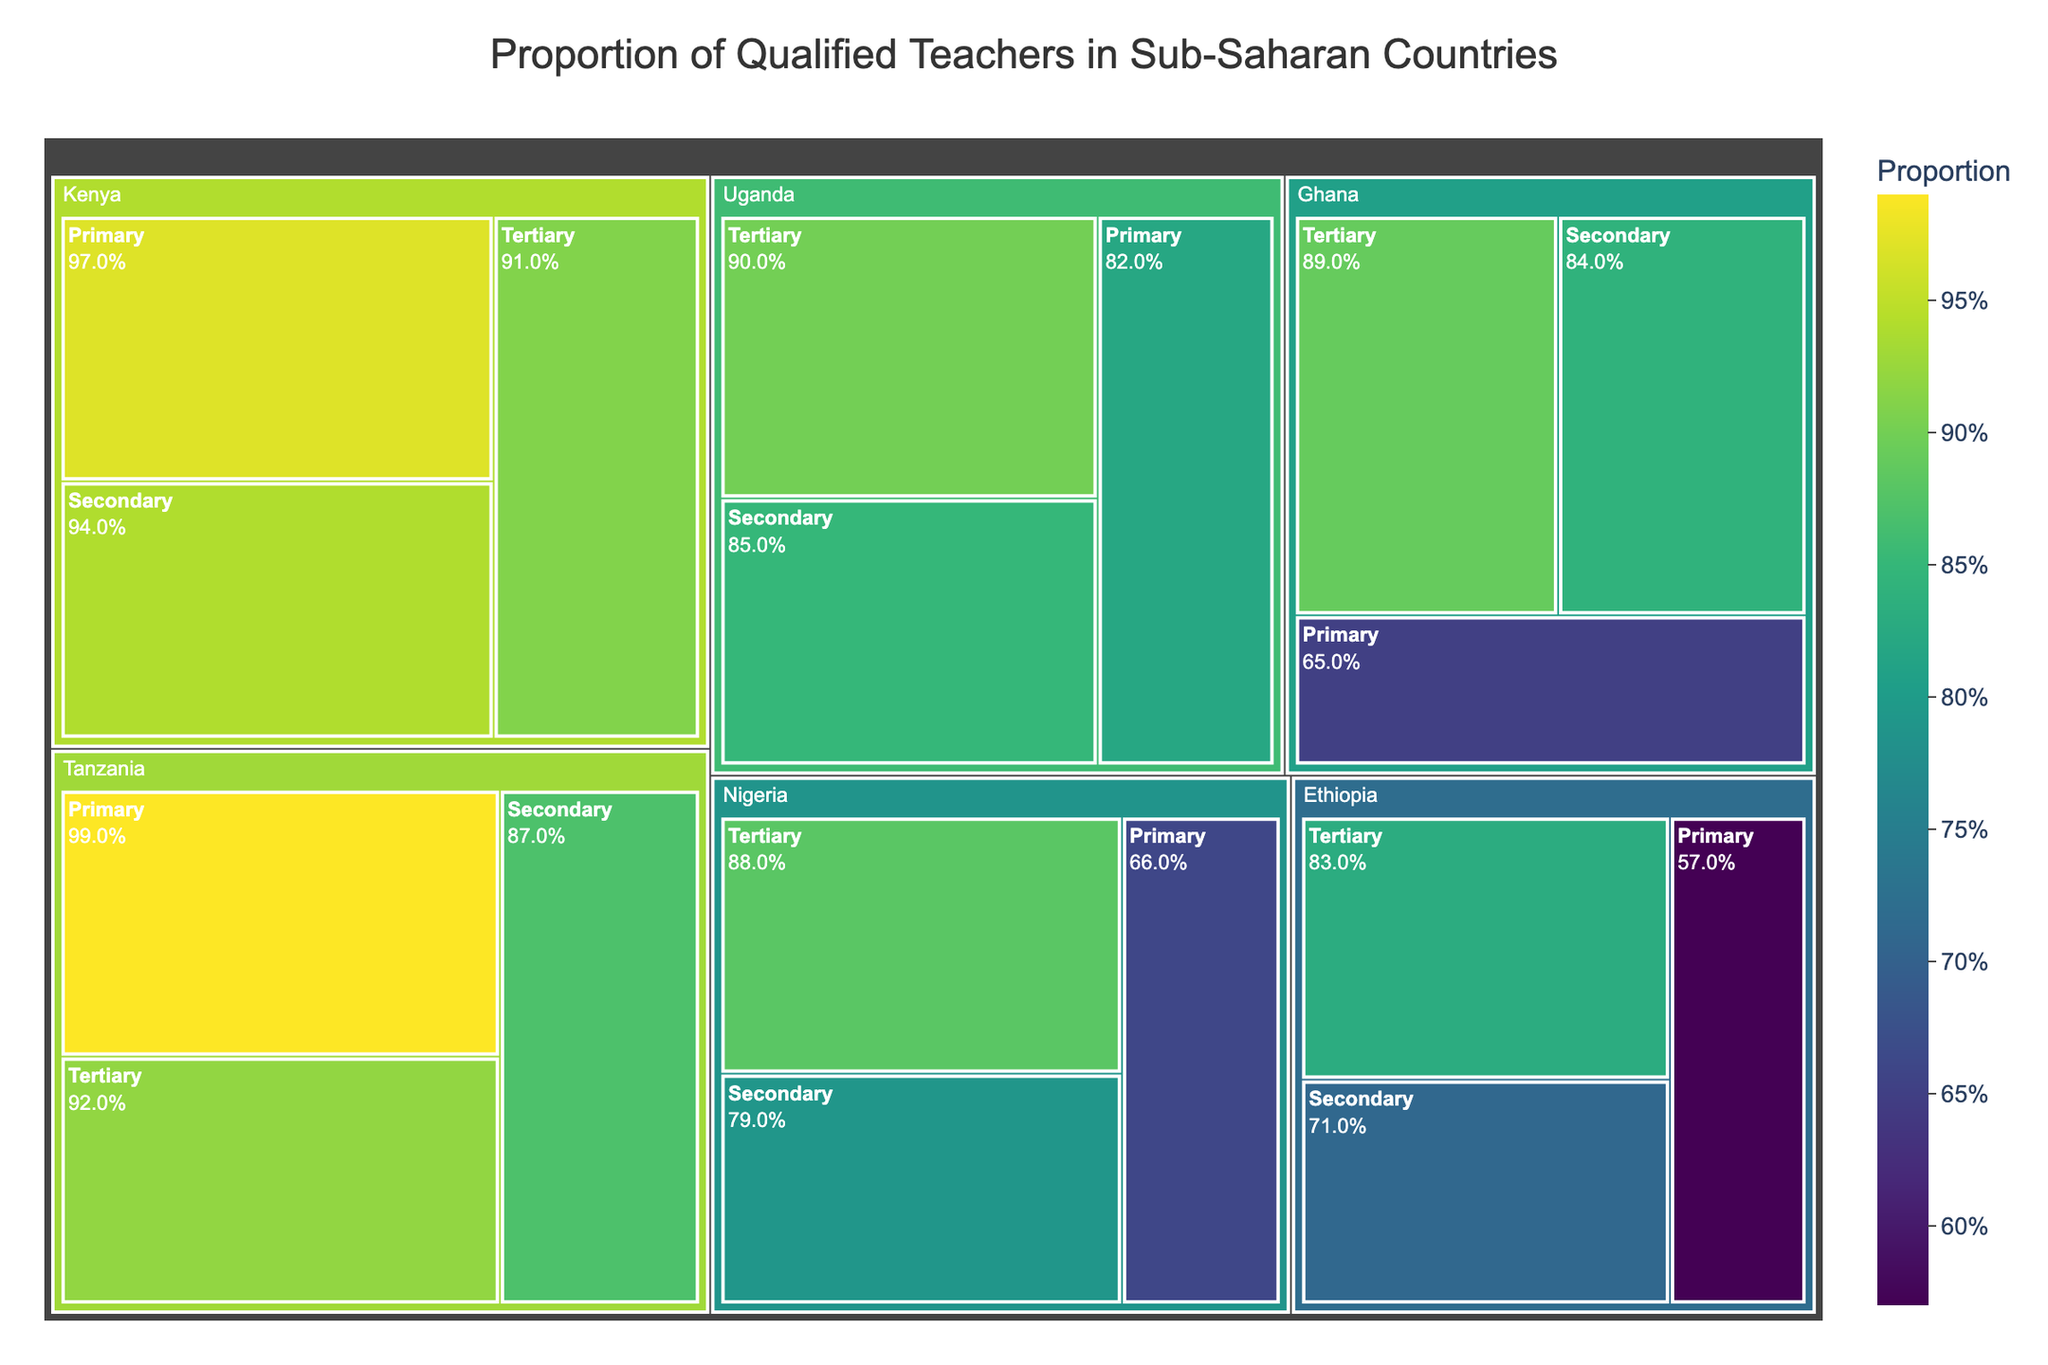What is the title of the treemap? The title is usually found at the top center of the plot. It provides a general idea of what the figure represents. In this case, the title describes the content of the treemap.
Answer: Proportion of Qualified Teachers in Sub-Saharan Countries Which country has the highest proportion of qualified primary school teachers? Look for the largest proportion in the section of the treemap corresponding to primary education. Identify the country associated with this section. Tanzania at 0.99 has the highest proportion.
Answer: Tanzania How does the proportion of qualified tertiary teachers in Uganda compare to that in Nigeria? Locate the sections for tertiary education in both Uganda and Nigeria. Compare the values to determine which is higher. Uganda has 0.90 and Nigeria has 0.88.
Answer: Uganda What is the range of the proportions of qualified secondary school teachers across all countries? Identify the minimum and maximum proportions from the sections representing secondary education in all the countries and find the difference. The lowest proportion is 0.71 (Ethiopia) and the highest is 0.94 (Kenya).
Answer: 0.23 What is the average proportion of qualified teachers at the primary education level across all listed countries? Sum the proportions of all countries in the Primary education section and divide by the number of countries (5). The sum is 0.66 + 0.97 + 0.57 + 0.65 + 0.99 + 0.82 = 4.66. The average is 4.66/6.
Answer: 0.78 Which education level in Tanzania has the lowest proportion of qualified teachers and what is the value? Look for the smallest section within Tanzania's part of the treemap and note its value. Secondary education at 0.87.
Answer: Secondary, 0.87 Is the proportion of qualified secondary teachers in Ethiopia greater than the overall average proportion of qualified secondary teachers? Calculate the overall average of secondary teachers across countries and compare it to Ethiopia's proportion. The average for secondary is (0.79 + 0.94 + 0.71 + 0.84 + 0.87 + 0.85)/6 = 0.833. Ethiopia's secondary proportion is 0.71, which is less.
Answer: No How many countries have a proportion of qualified tertiary teachers greater than 0.90? Count the number of countries where the proportion in the tertiary section exceeds 0.90. Kenya and Tanzania have values greater than 0.90.
Answer: 2 Which country shows the smallest difference between the proportions of qualified secondary and tertiary teachers? Calculate the difference between secondary and tertiary proportions for each country and identify the smallest difference. Nigeria: 0.88 - 0.79 = 0.09, Kenya: 0.91 - 0.94 = 0.03, Ethiopia: 0.83 - 0.71 = 0.12, Ghana: 0.89 - 0.84 = 0.05, Tanzania: 0.92 - 0.87 = 0.05, Uganda: 0.90 - 0.85 = 0.05. The smallest difference is 0.03 in Kenya.
Answer: Kenya 